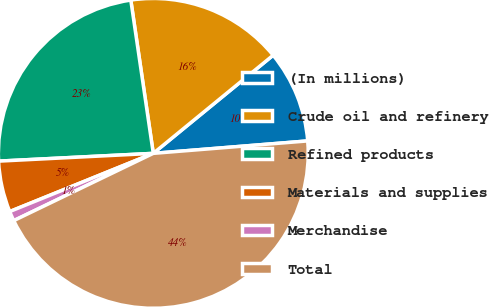<chart> <loc_0><loc_0><loc_500><loc_500><pie_chart><fcel>(In millions)<fcel>Crude oil and refinery<fcel>Refined products<fcel>Materials and supplies<fcel>Merchandise<fcel>Total<nl><fcel>9.64%<fcel>16.4%<fcel>23.48%<fcel>5.33%<fcel>1.02%<fcel>44.13%<nl></chart> 